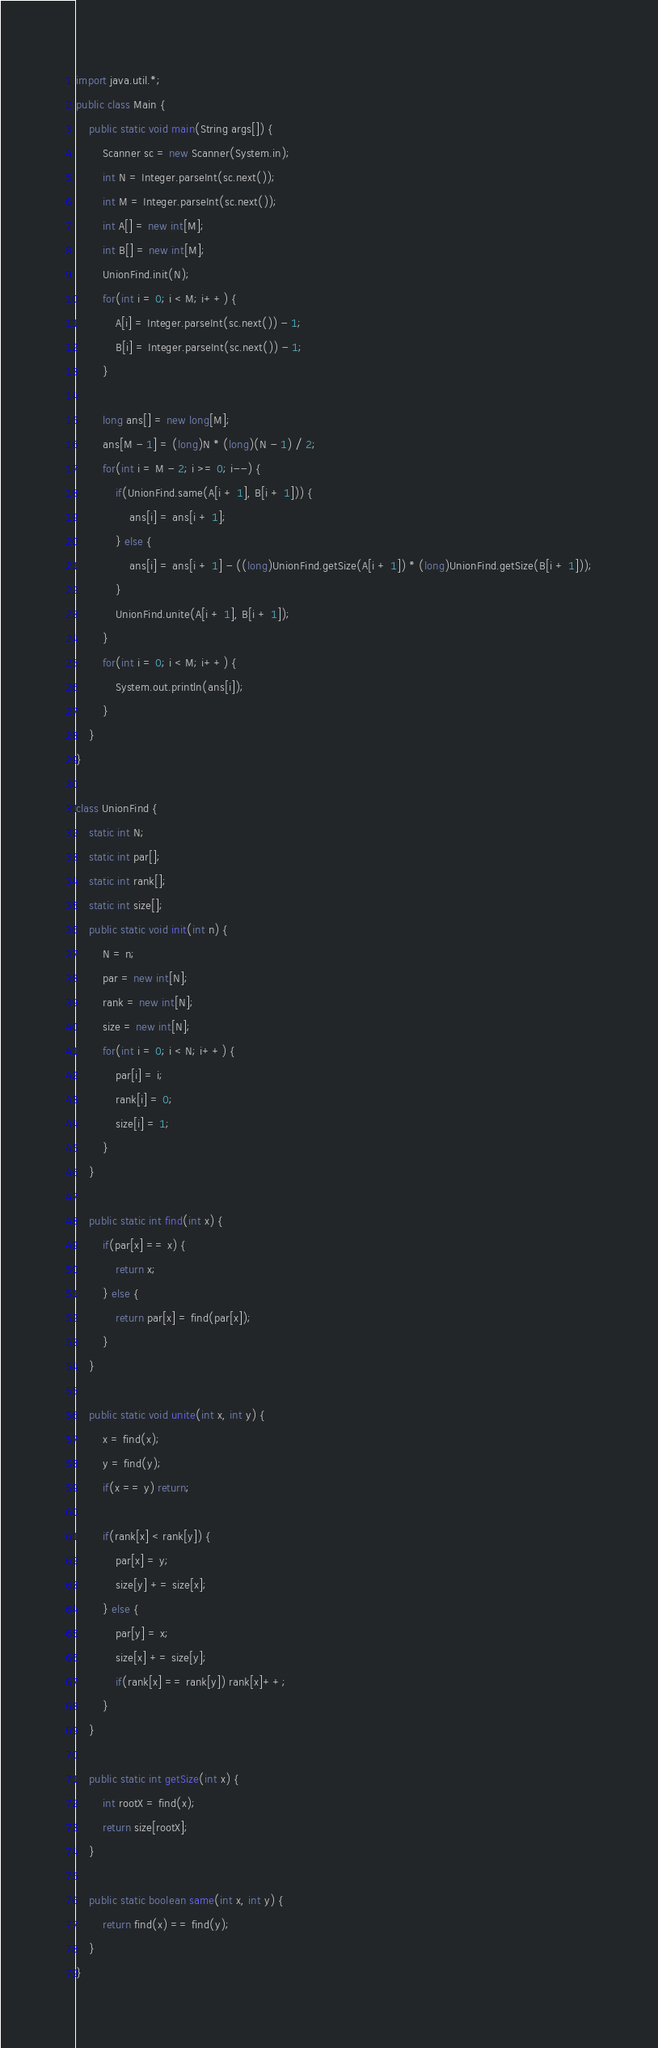<code> <loc_0><loc_0><loc_500><loc_500><_Java_>import java.util.*;
public class Main {
	public static void main(String args[]) {
		Scanner sc = new Scanner(System.in);
		int N = Integer.parseInt(sc.next());
		int M = Integer.parseInt(sc.next());
		int A[] = new int[M];
		int B[] = new int[M];
		UnionFind.init(N);
		for(int i = 0; i < M; i++) {
			A[i] = Integer.parseInt(sc.next()) - 1;
			B[i] = Integer.parseInt(sc.next()) - 1;
		}
		
		long ans[] = new long[M];
		ans[M - 1] = (long)N * (long)(N - 1) / 2;
		for(int i = M - 2; i >= 0; i--) {
			if(UnionFind.same(A[i + 1], B[i + 1])) {
				ans[i] = ans[i + 1];
			} else {
				ans[i] = ans[i + 1] - ((long)UnionFind.getSize(A[i + 1]) * (long)UnionFind.getSize(B[i + 1]));
			}
			UnionFind.unite(A[i + 1], B[i + 1]);
		}
		for(int i = 0; i < M; i++) {
			System.out.println(ans[i]);
		}
	}
}

class UnionFind {
	static int N;
	static int par[];
	static int rank[];
	static int size[];
	public static void init(int n) {
		N = n;
		par = new int[N];
		rank = new int[N];
		size = new int[N];
		for(int i = 0; i < N; i++) {
			par[i] = i;
			rank[i] = 0;
			size[i] = 1;
		}
	}

	public static int find(int x) {
		if(par[x] == x) {
			return x;
		} else {
			return par[x] = find(par[x]);
		}
	}
	
	public static void unite(int x, int y) {
		x = find(x);
		y = find(y);
		if(x == y) return;
		
		if(rank[x] < rank[y]) {
			par[x] = y;
			size[y] += size[x];
		} else {
			par[y] = x;
			size[x] += size[y];
			if(rank[x] == rank[y]) rank[x]++;
		}
	}
	
	public static int getSize(int x) {
		int rootX = find(x);
		return size[rootX];
	}
	
	public static boolean same(int x, int y) {
		return find(x) == find(y);
	}
}
</code> 